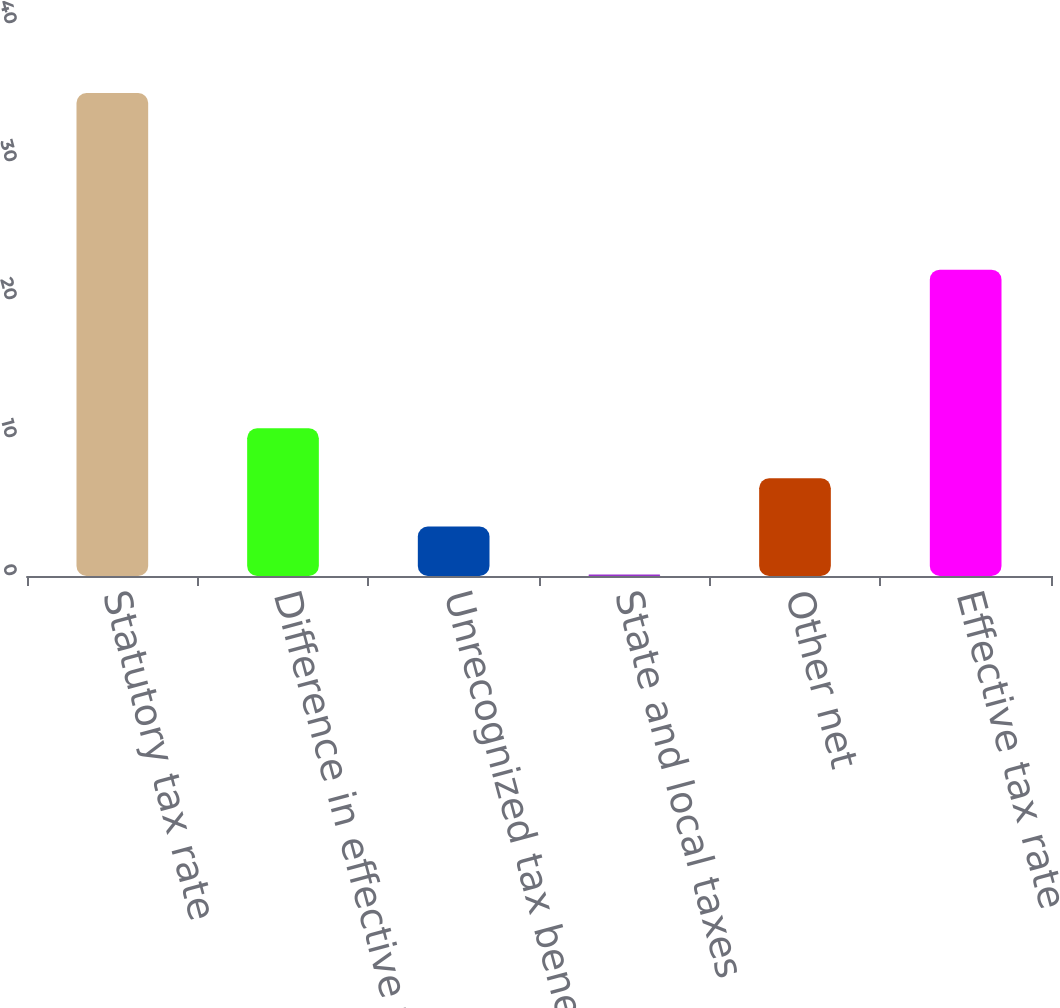<chart> <loc_0><loc_0><loc_500><loc_500><bar_chart><fcel>Statutory tax rate<fcel>Difference in effective tax<fcel>Unrecognized tax benefit net<fcel>State and local taxes<fcel>Other net<fcel>Effective tax rate<nl><fcel>35<fcel>10.7<fcel>3.59<fcel>0.1<fcel>7.08<fcel>22.2<nl></chart> 